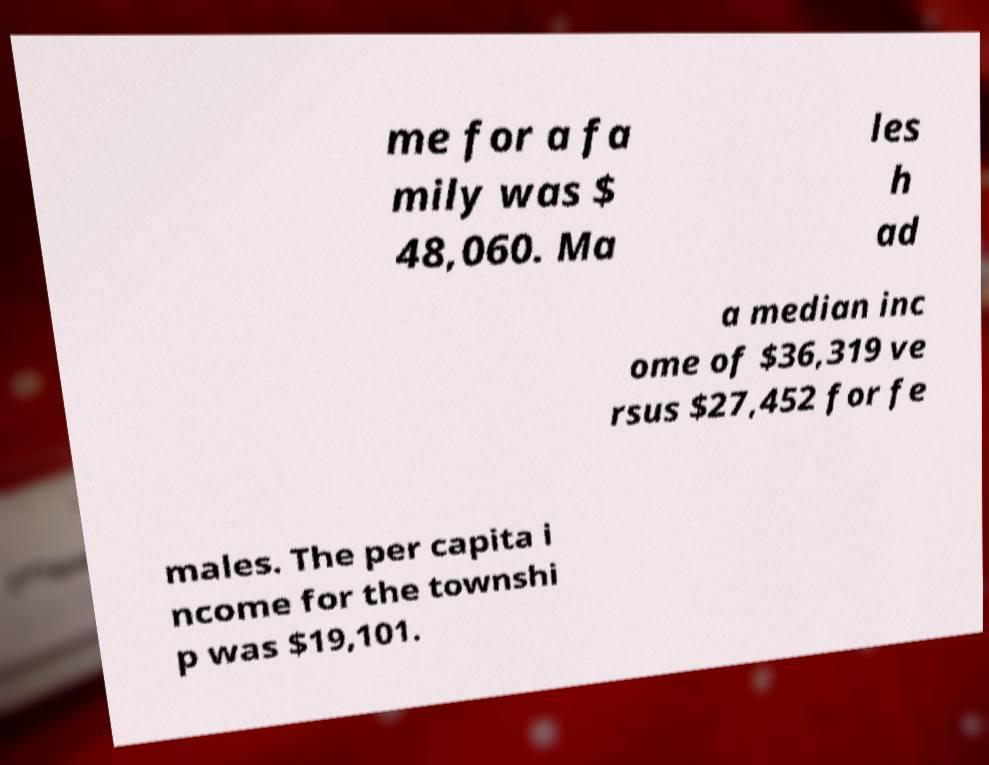Please read and relay the text visible in this image. What does it say? me for a fa mily was $ 48,060. Ma les h ad a median inc ome of $36,319 ve rsus $27,452 for fe males. The per capita i ncome for the townshi p was $19,101. 